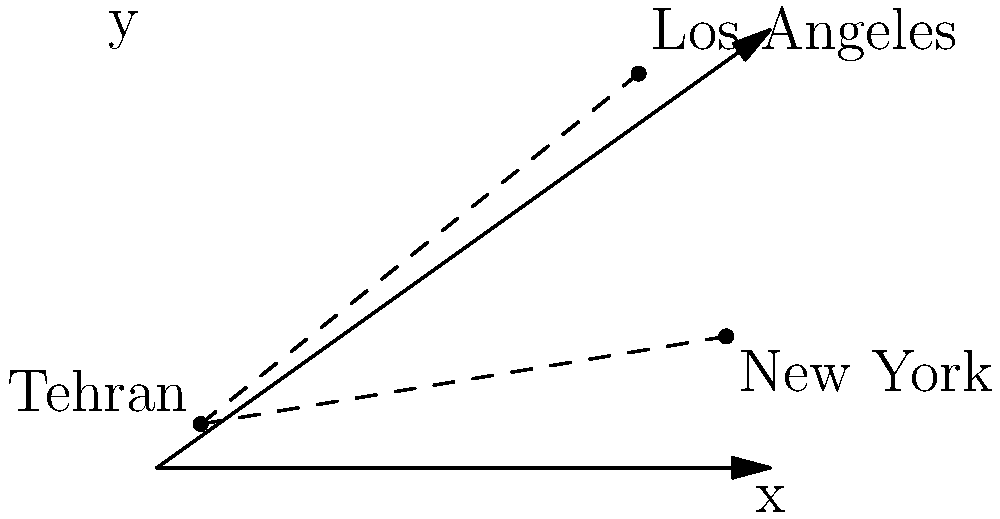On a 2D coordinate map, Tehran is located at $(0,0)$, Los Angeles at $(10,8)$, and New York at $(12,2)$. As a fan of Shab who migrated from Iran to the US, you're curious about the distances between these cities. Calculate the difference between the distance from Tehran to Los Angeles and the distance from Tehran to New York, rounded to two decimal places. Let's approach this step-by-step:

1) First, we need to calculate the distance from Tehran to Los Angeles:
   Using the distance formula: $d = \sqrt{(x_2-x_1)^2 + (y_2-y_1)^2}$
   $d_{TL} = \sqrt{(10-0)^2 + (8-0)^2} = \sqrt{100 + 64} = \sqrt{164} \approx 12.81$

2) Next, let's calculate the distance from Tehran to New York:
   $d_{TN} = \sqrt{(12-0)^2 + (2-0)^2} = \sqrt{144 + 4} = \sqrt{148} \approx 12.17$

3) Now, we need to find the difference between these distances:
   $\text{Difference} = d_{TL} - d_{TN} = 12.81 - 12.17 = 0.64$

4) Rounding to two decimal places, we get 0.64.

This result shows that on this 2D map, Los Angeles is slightly farther from Tehran than New York is, by about 0.64 units.
Answer: $0.64$ 